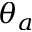Convert formula to latex. <formula><loc_0><loc_0><loc_500><loc_500>\theta _ { a }</formula> 